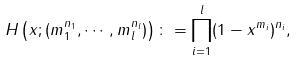Convert formula to latex. <formula><loc_0><loc_0><loc_500><loc_500>H \left ( x ; ( m _ { 1 } ^ { n _ { 1 } } , \cdots , m _ { l } ^ { n _ { l } } ) \right ) \colon = \prod _ { i = 1 } ^ { l } ( 1 - x ^ { m _ { i } } ) ^ { n _ { i } } ,</formula> 